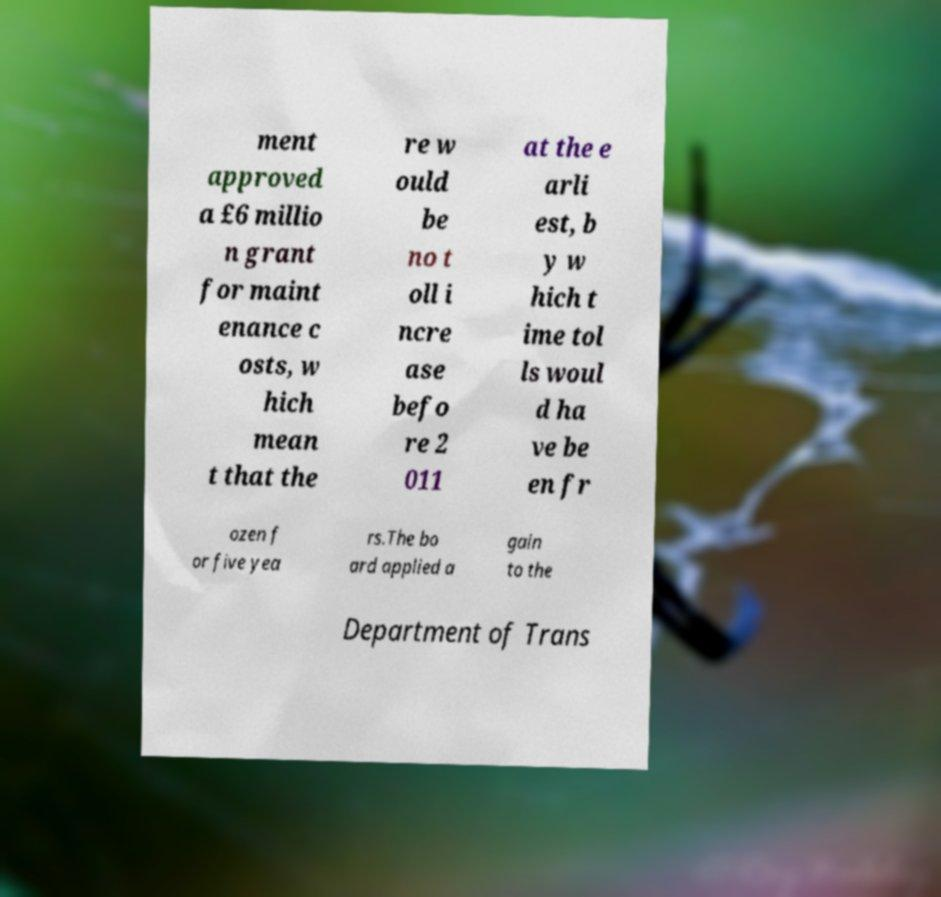I need the written content from this picture converted into text. Can you do that? ment approved a £6 millio n grant for maint enance c osts, w hich mean t that the re w ould be no t oll i ncre ase befo re 2 011 at the e arli est, b y w hich t ime tol ls woul d ha ve be en fr ozen f or five yea rs.The bo ard applied a gain to the Department of Trans 